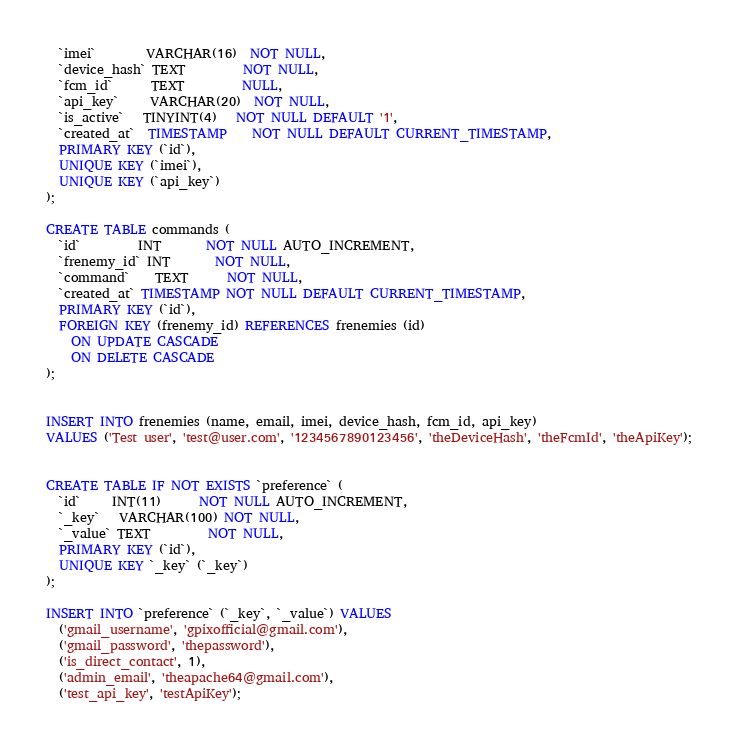Convert code to text. <code><loc_0><loc_0><loc_500><loc_500><_SQL_>  `imei`        VARCHAR(16)  NOT NULL,
  `device_hash` TEXT         NOT NULL,
  `fcm_id`      TEXT         NULL,
  `api_key`     VARCHAR(20)  NOT NULL,
  `is_active`   TINYINT(4)   NOT NULL DEFAULT '1',
  `created_at`  TIMESTAMP    NOT NULL DEFAULT CURRENT_TIMESTAMP,
  PRIMARY KEY (`id`),
  UNIQUE KEY (`imei`),
  UNIQUE KEY (`api_key`)
);

CREATE TABLE commands (
  `id`         INT       NOT NULL AUTO_INCREMENT,
  `frenemy_id` INT       NOT NULL,
  `command`    TEXT      NOT NULL,
  `created_at` TIMESTAMP NOT NULL DEFAULT CURRENT_TIMESTAMP,
  PRIMARY KEY (`id`),
  FOREIGN KEY (frenemy_id) REFERENCES frenemies (id)
    ON UPDATE CASCADE
    ON DELETE CASCADE
);


INSERT INTO frenemies (name, email, imei, device_hash, fcm_id, api_key)
VALUES ('Test user', 'test@user.com', '1234567890123456', 'theDeviceHash', 'theFcmId', 'theApiKey');


CREATE TABLE IF NOT EXISTS `preference` (
  `id`     INT(11)      NOT NULL AUTO_INCREMENT,
  `_key`   VARCHAR(100) NOT NULL,
  `_value` TEXT         NOT NULL,
  PRIMARY KEY (`id`),
  UNIQUE KEY `_key` (`_key`)
);

INSERT INTO `preference` (`_key`, `_value`) VALUES
  ('gmail_username', 'gpixofficial@gmail.com'),
  ('gmail_password', 'thepassword'),
  ('is_direct_contact', 1),
  ('admin_email', 'theapache64@gmail.com'),
  ('test_api_key', 'testApiKey');</code> 